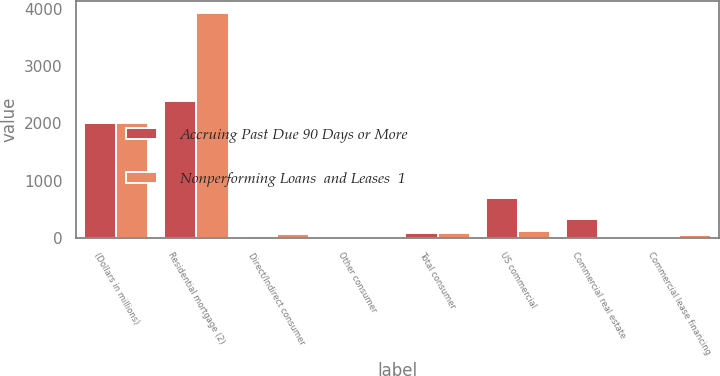Convert chart. <chart><loc_0><loc_0><loc_500><loc_500><stacked_bar_chart><ecel><fcel>(Dollars in millions)<fcel>Residential mortgage (2)<fcel>Direct/Indirect consumer<fcel>Other consumer<fcel>Total consumer<fcel>US commercial<fcel>Commercial real estate<fcel>Commercial lease financing<nl><fcel>Accruing Past Due 90 Days or More<fcel>2014<fcel>2398<fcel>28<fcel>1<fcel>87<fcel>701<fcel>321<fcel>3<nl><fcel>Nonperforming Loans  and Leases  1<fcel>2014<fcel>3942<fcel>64<fcel>1<fcel>87<fcel>110<fcel>3<fcel>41<nl></chart> 